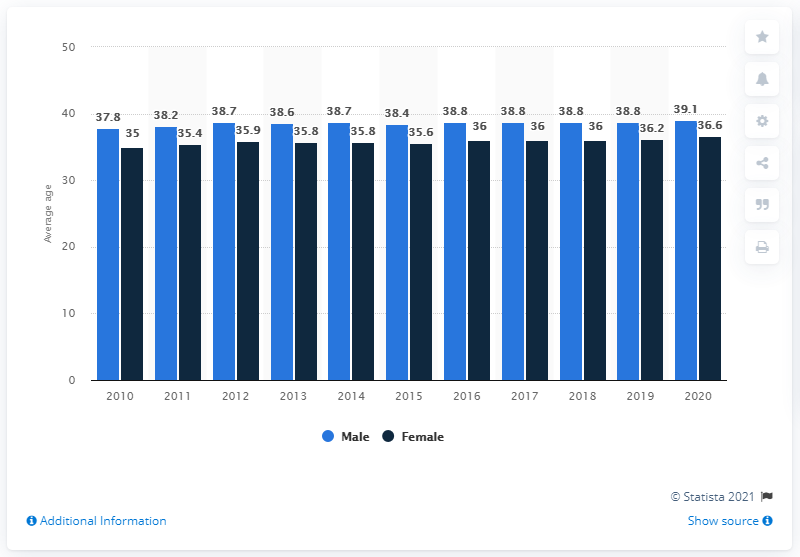Draw attention to some important aspects in this diagram. The average age at marriage in Denmark in 2010 was 36.4 years old. According to data from 2010, the average age of marriage for males in Denmark was 37.8 years old. 